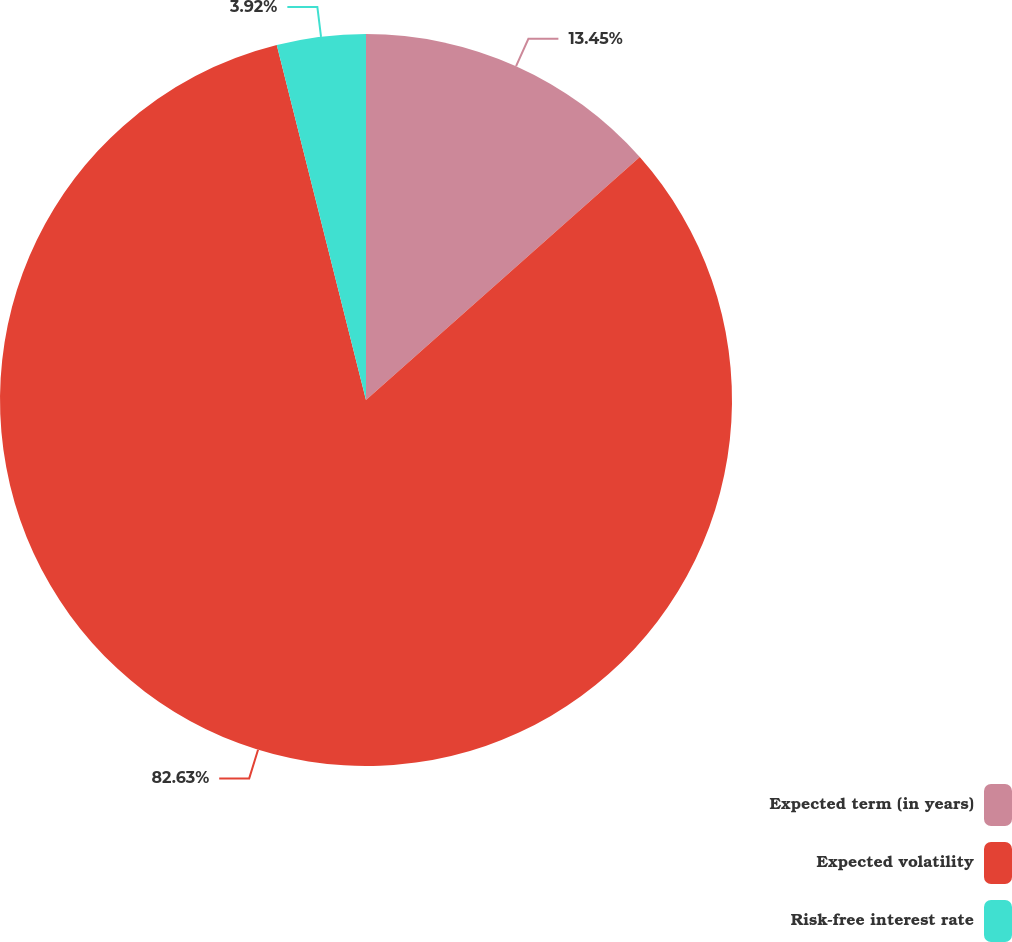<chart> <loc_0><loc_0><loc_500><loc_500><pie_chart><fcel>Expected term (in years)<fcel>Expected volatility<fcel>Risk-free interest rate<nl><fcel>13.45%<fcel>82.63%<fcel>3.92%<nl></chart> 